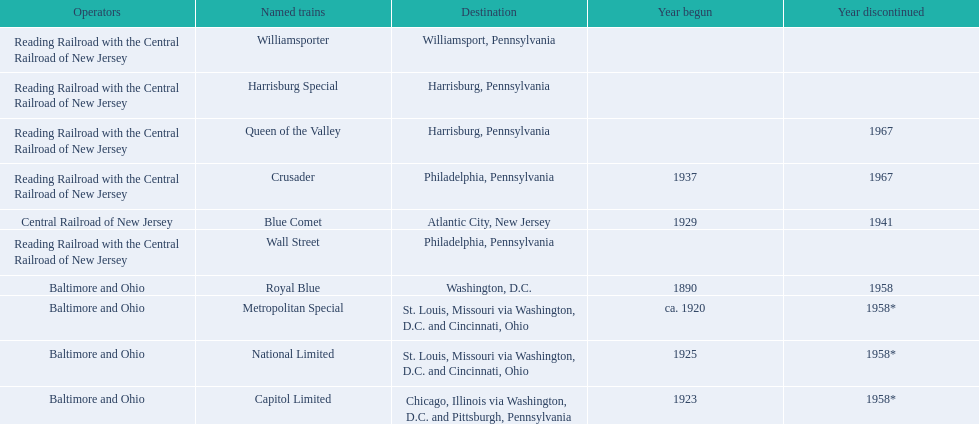What destinations are there? Chicago, Illinois via Washington, D.C. and Pittsburgh, Pennsylvania, St. Louis, Missouri via Washington, D.C. and Cincinnati, Ohio, St. Louis, Missouri via Washington, D.C. and Cincinnati, Ohio, Washington, D.C., Atlantic City, New Jersey, Philadelphia, Pennsylvania, Harrisburg, Pennsylvania, Harrisburg, Pennsylvania, Philadelphia, Pennsylvania, Williamsport, Pennsylvania. Which one is at the top of the list? Chicago, Illinois via Washington, D.C. and Pittsburgh, Pennsylvania. 